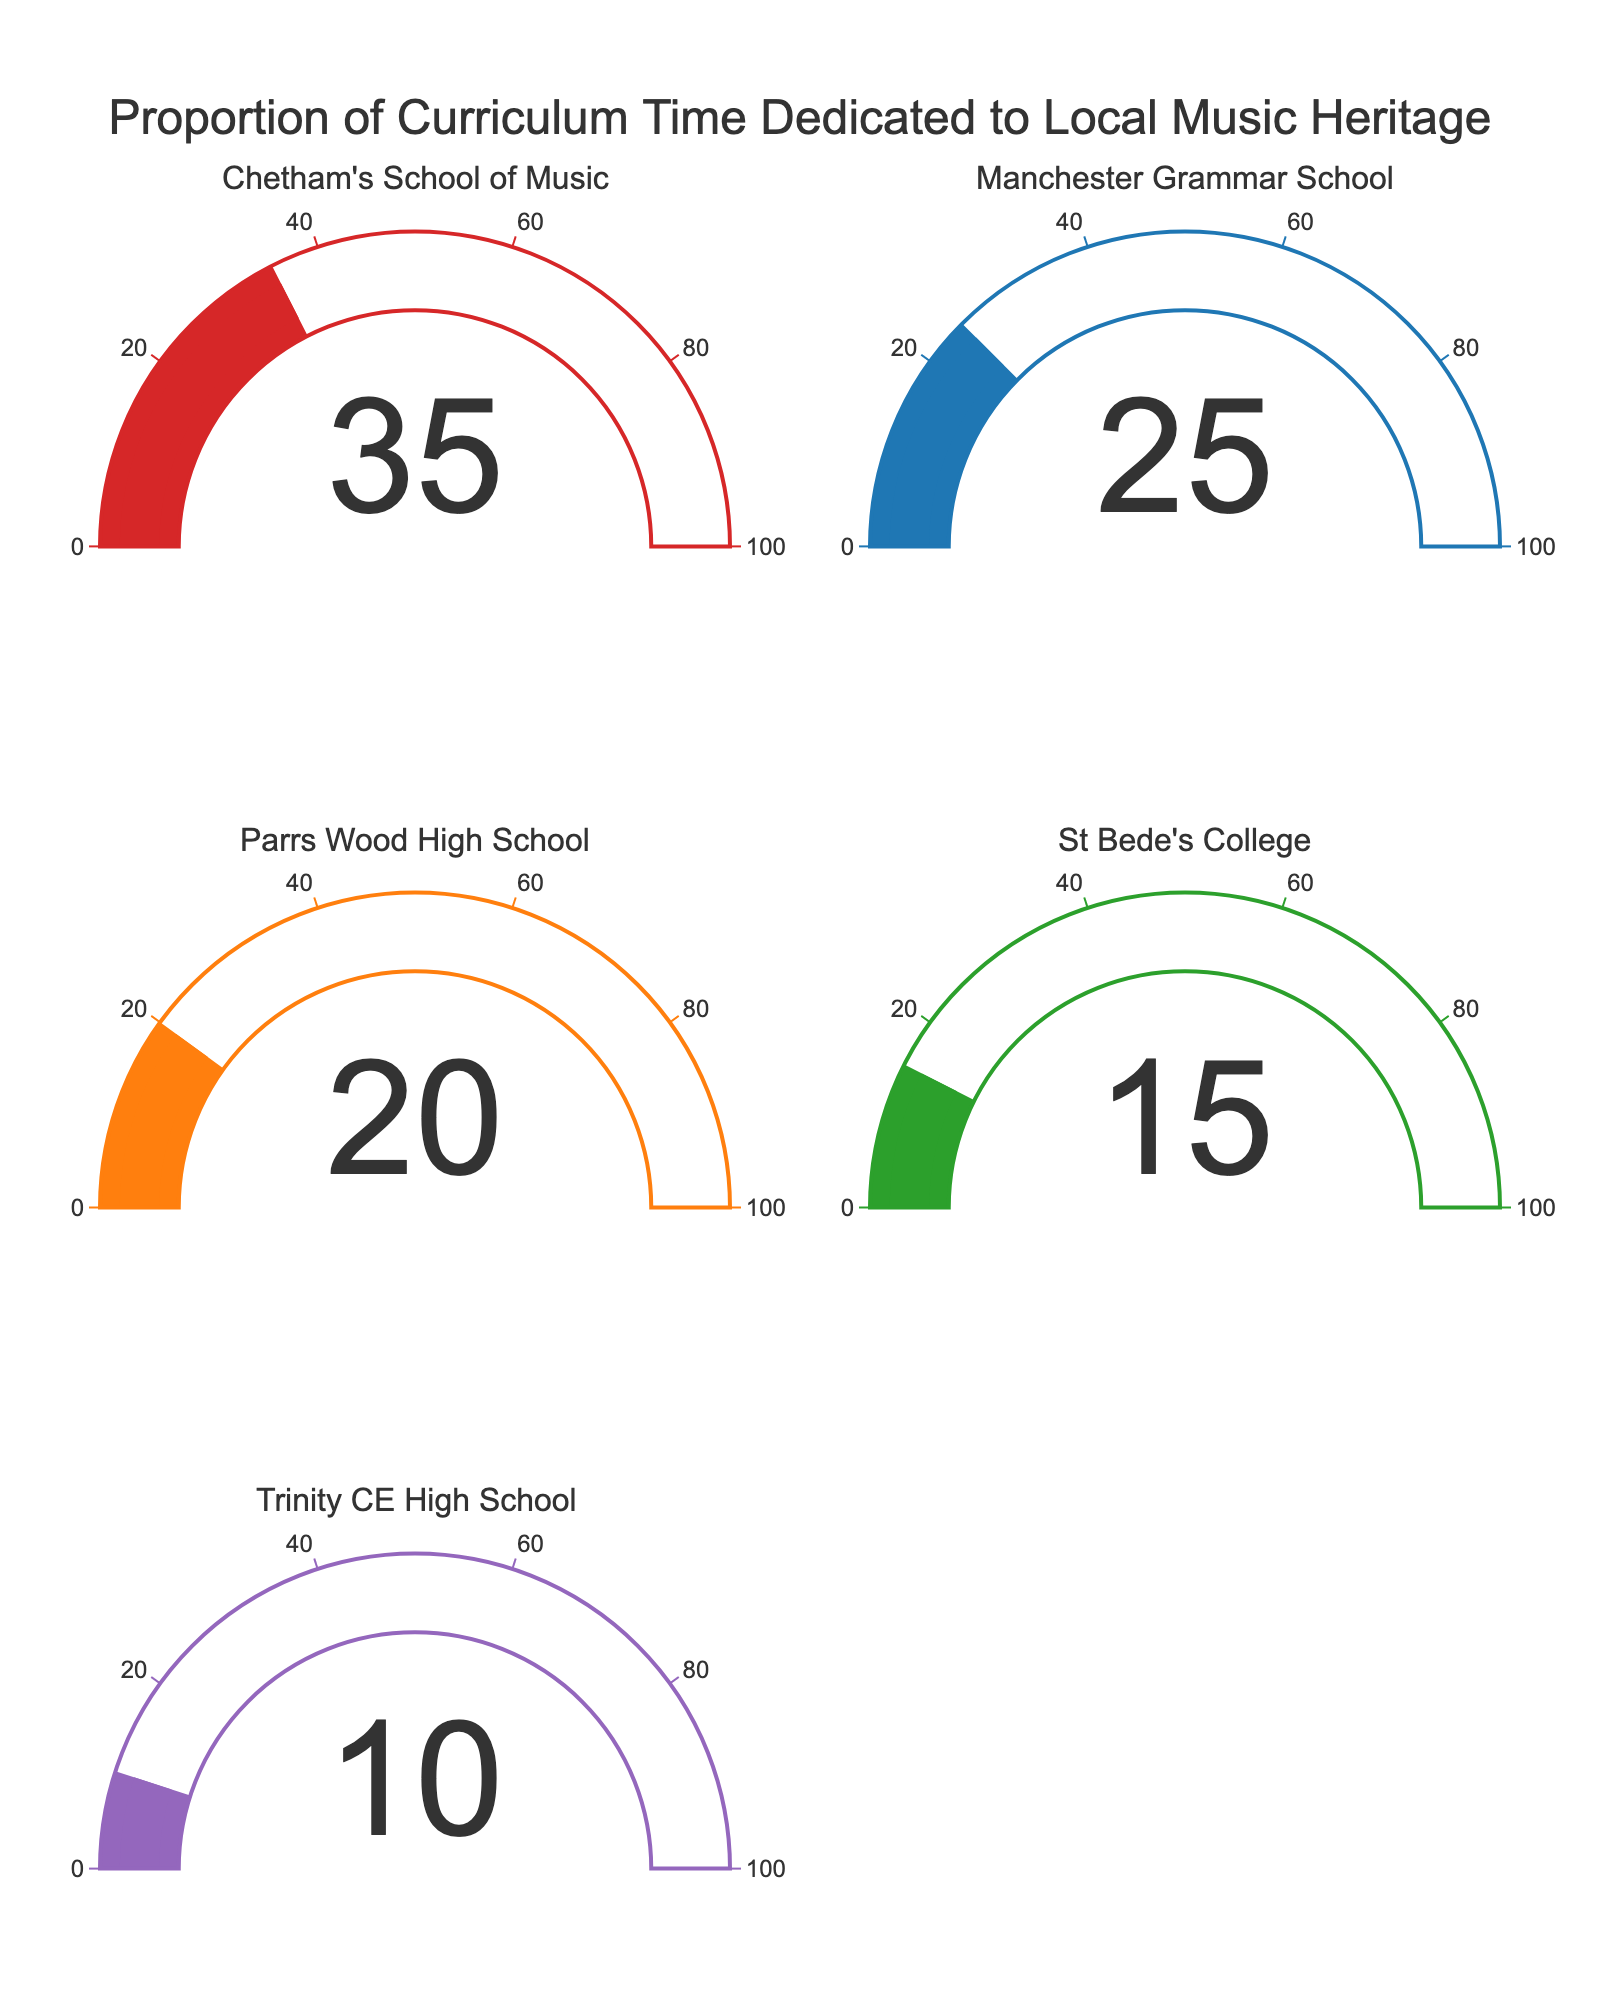Which school dedicates the highest proportion of curriculum time to local music heritage? Find the gauge with the highest percentage value. Chetham's School of Music shows the highest at 35%.
Answer: Chetham's School of Music Which school dedicates the lowest proportion of curriculum time to local music heritage? Find the gauge with the lowest percentage value. Trinity CE High School shows the lowest at 10%.
Answer: Trinity CE High School What is the difference in curriculum time dedicated to local music heritage between the top and bottom schools? Subtract the smallest value from the largest value. 35% (Chetham's School of Music) - 10% (Trinity CE High School) = 25%.
Answer: 25% What is the average proportion of curriculum time dedicated to local music heritage across all schools? Sum the percentages and divide by the number of schools (5). (35 + 25 + 20 + 15 + 10) / 5 = 21%.
Answer: 21% How many schools dedicate 20% or more of their curriculum time to local music heritage? Count the number of gauges with values 20% or more. Chetham's School of Music, Manchester Grammar School, and Parrs Wood High School all have 20% or more.
Answer: 3 What is the combined proportion of curriculum time dedicated to local music heritage by Manchester Grammar School and Parrs Wood High School? Add their percentages. 25% (Manchester Grammar School) + 20% (Parrs Wood High School) = 45%.
Answer: 45% Which two schools have the closest proportions of curriculum time dedicated to local music heritage? Calculate the differences between all pairs and find the smallest difference. Manchester Grammar School (25%) and Parrs Wood High School (20%) differ by 5%.
Answer: Manchester Grammar School and Parrs Wood High School Is the percentage of curriculum time dedicated to local music heritage at St Bede's College greater than at Trinity CE High School? Compare the percentages. St Bede's College has 15% and Trinity CE High School has 10%, so yes.
Answer: Yes What's the total percentage of curriculum time dedicated to local music heritage for the schools that dedicate less than 20%? Find schools with less than 20% and sum their percentages. 15% (St Bede's College) + 10% (Trinity CE High School) = 25%.
Answer: 25% Which color represents the data for Parrs Wood High School? Identify the color used for Parrs Wood High School. The gauge is depicted with orange.
Answer: Orange 